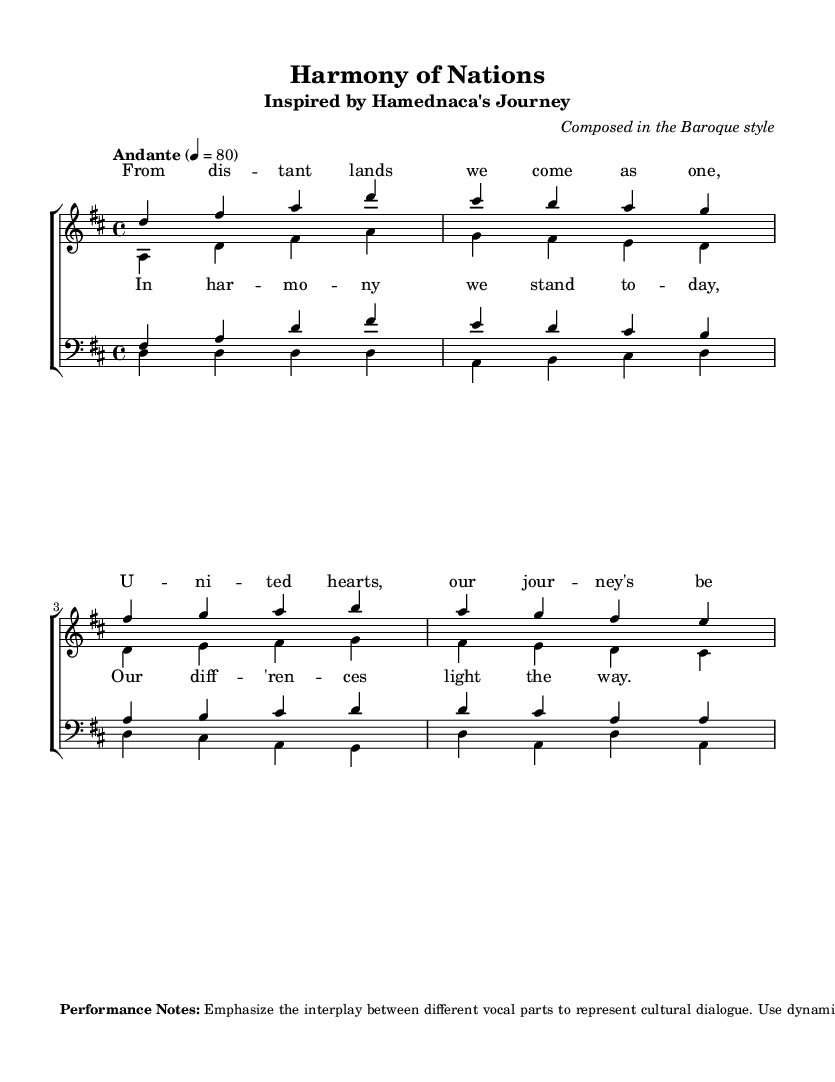What is the key signature of this music? The key signature of this piece is D major, which contains two sharps (F# and C#). This can be determined by looking at the key signature notation at the beginning of the score.
Answer: D major What is the time signature of this music? The time signature displayed at the start of the music indicates four beats per measure, as shown by the "4/4" notation. This means there are four quarter note beats in each measure.
Answer: 4/4 What is the tempo marking? The tempo marking is indicated as "Andante," which denotes a moderate pace. This is confirmed by the word "Andante" followed by the tempo value of 4 = 80 at the beginning of the score.
Answer: Andante What are the vocal parts featured in this choral work? The vocal parts include sopranos, altos, tenors, and basses. These parts are labeled clearly in the score, and the respective staves show the arrangement of the voices for performance.
Answer: Sopranos, altos, tenors, basses What is the central theme expressed in the lyrics? The lyrics highlight unity and cultural diversity, expressing a journey of coming together from different backgrounds. This is evident from phrases such as "From distant lands we come as one" and "Our differences light the way."
Answer: Unity and cultural diversity How does the structure of this choral piece reflect Baroque characteristics? The structure features distinct vocal lines for each choir part that interweave and harmonize, a hallmark of Baroque chorale music. Additionally, there is an emphasis on counterpoint and the interplay between voices, typical of the Baroque style.
Answer: Interweaving vocal lines 